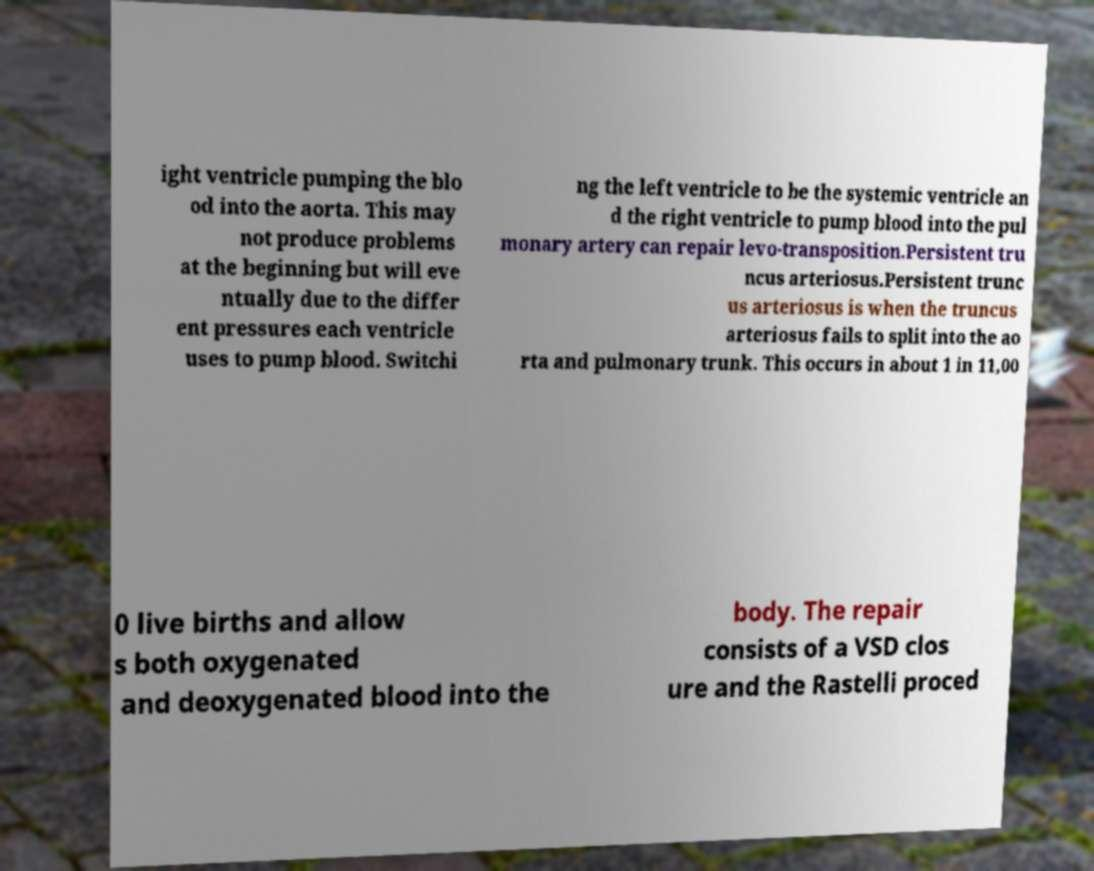Can you read and provide the text displayed in the image?This photo seems to have some interesting text. Can you extract and type it out for me? ight ventricle pumping the blo od into the aorta. This may not produce problems at the beginning but will eve ntually due to the differ ent pressures each ventricle uses to pump blood. Switchi ng the left ventricle to be the systemic ventricle an d the right ventricle to pump blood into the pul monary artery can repair levo-transposition.Persistent tru ncus arteriosus.Persistent trunc us arteriosus is when the truncus arteriosus fails to split into the ao rta and pulmonary trunk. This occurs in about 1 in 11,00 0 live births and allow s both oxygenated and deoxygenated blood into the body. The repair consists of a VSD clos ure and the Rastelli proced 